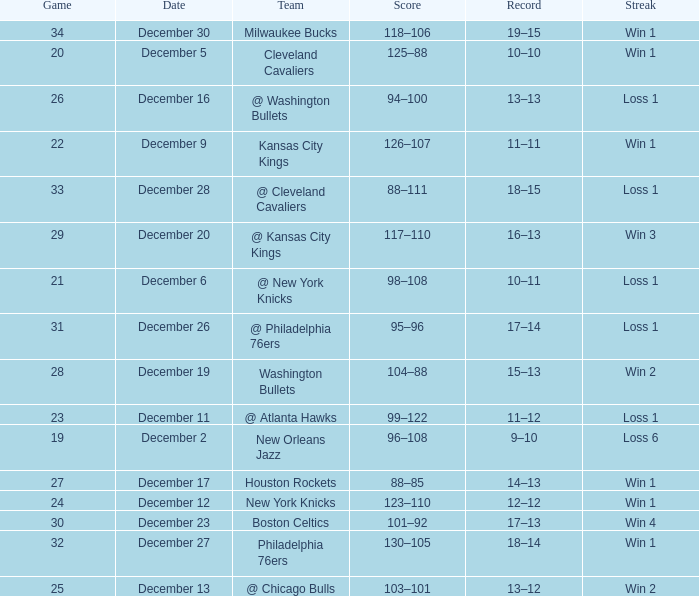What is the Score of the Game with a Record of 13–12? 103–101. 